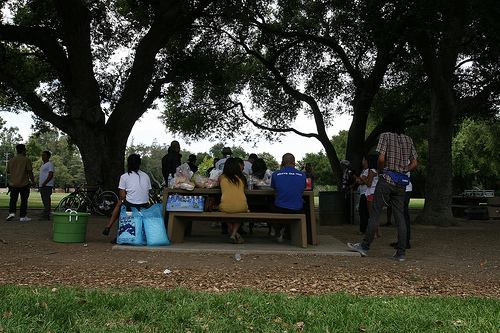<image>
Is the tree in front of the woman? Yes. The tree is positioned in front of the woman, appearing closer to the camera viewpoint. 